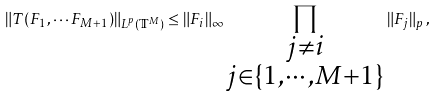<formula> <loc_0><loc_0><loc_500><loc_500>\| T ( F _ { 1 } , \cdots F _ { M + 1 } ) \| _ { L ^ { p } ( \mathbb { T } ^ { M } ) } \leq \| F _ { i } \| _ { \infty } \prod _ { { \substack { j \neq i \\ j \in \{ 1 , \cdots , M + 1 \} } } } \| F _ { j } \| _ { p } \, ,</formula> 